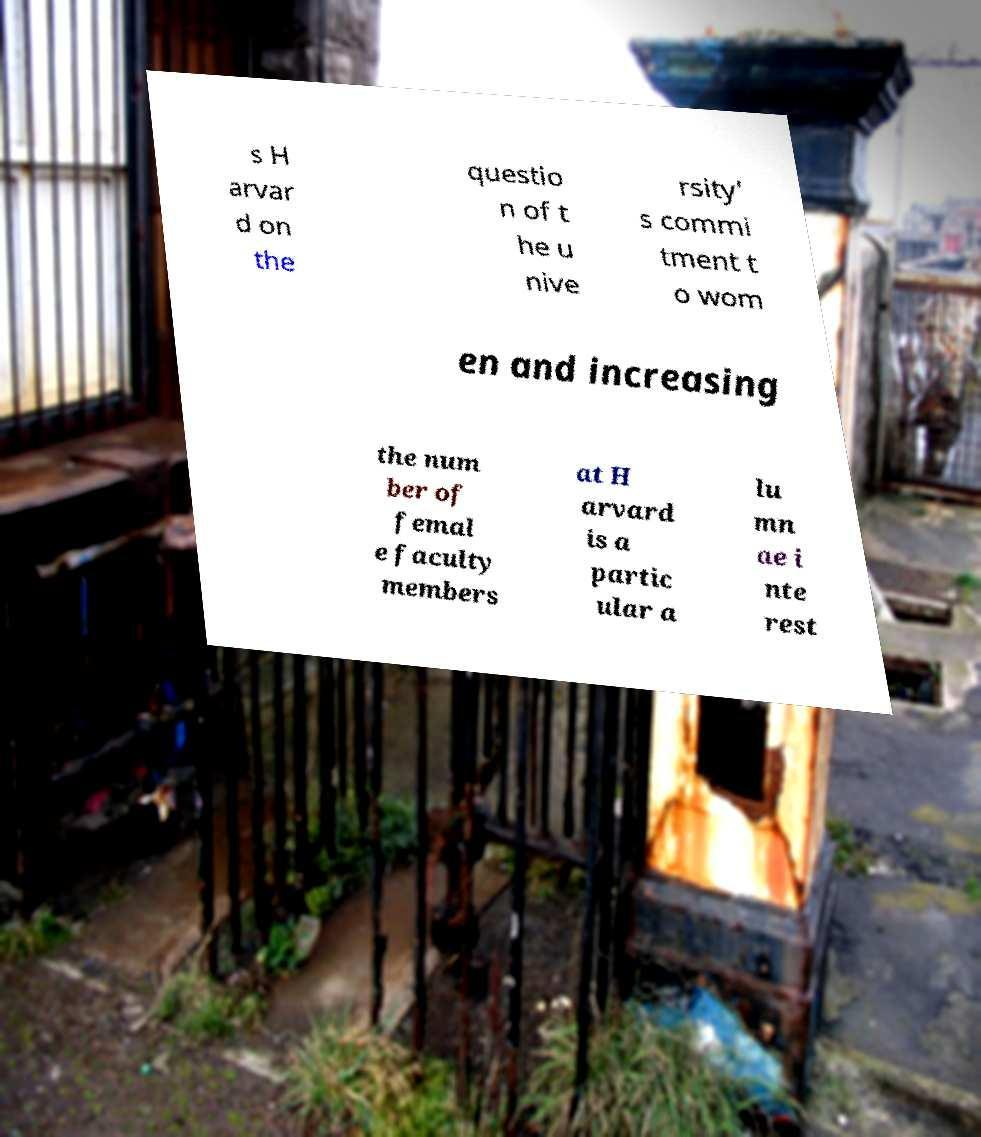Could you assist in decoding the text presented in this image and type it out clearly? s H arvar d on the questio n of t he u nive rsity' s commi tment t o wom en and increasing the num ber of femal e faculty members at H arvard is a partic ular a lu mn ae i nte rest 